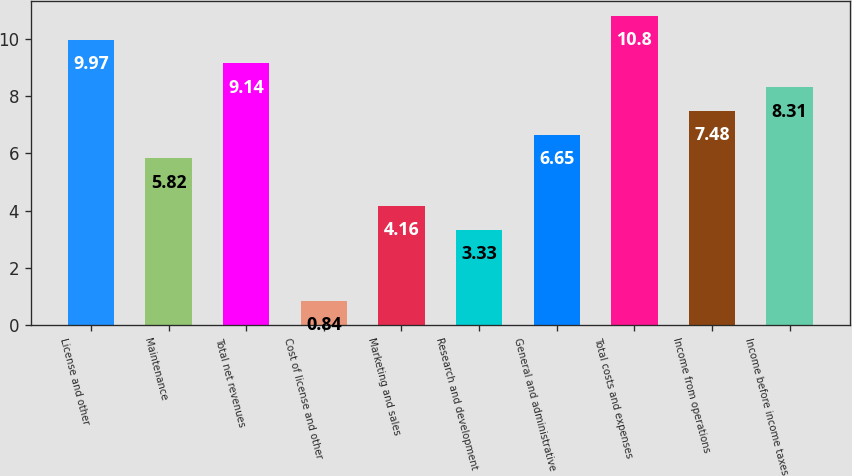Convert chart. <chart><loc_0><loc_0><loc_500><loc_500><bar_chart><fcel>License and other<fcel>Maintenance<fcel>Total net revenues<fcel>Cost of license and other<fcel>Marketing and sales<fcel>Research and development<fcel>General and administrative<fcel>Total costs and expenses<fcel>Income from operations<fcel>Income before income taxes<nl><fcel>9.97<fcel>5.82<fcel>9.14<fcel>0.84<fcel>4.16<fcel>3.33<fcel>6.65<fcel>10.8<fcel>7.48<fcel>8.31<nl></chart> 